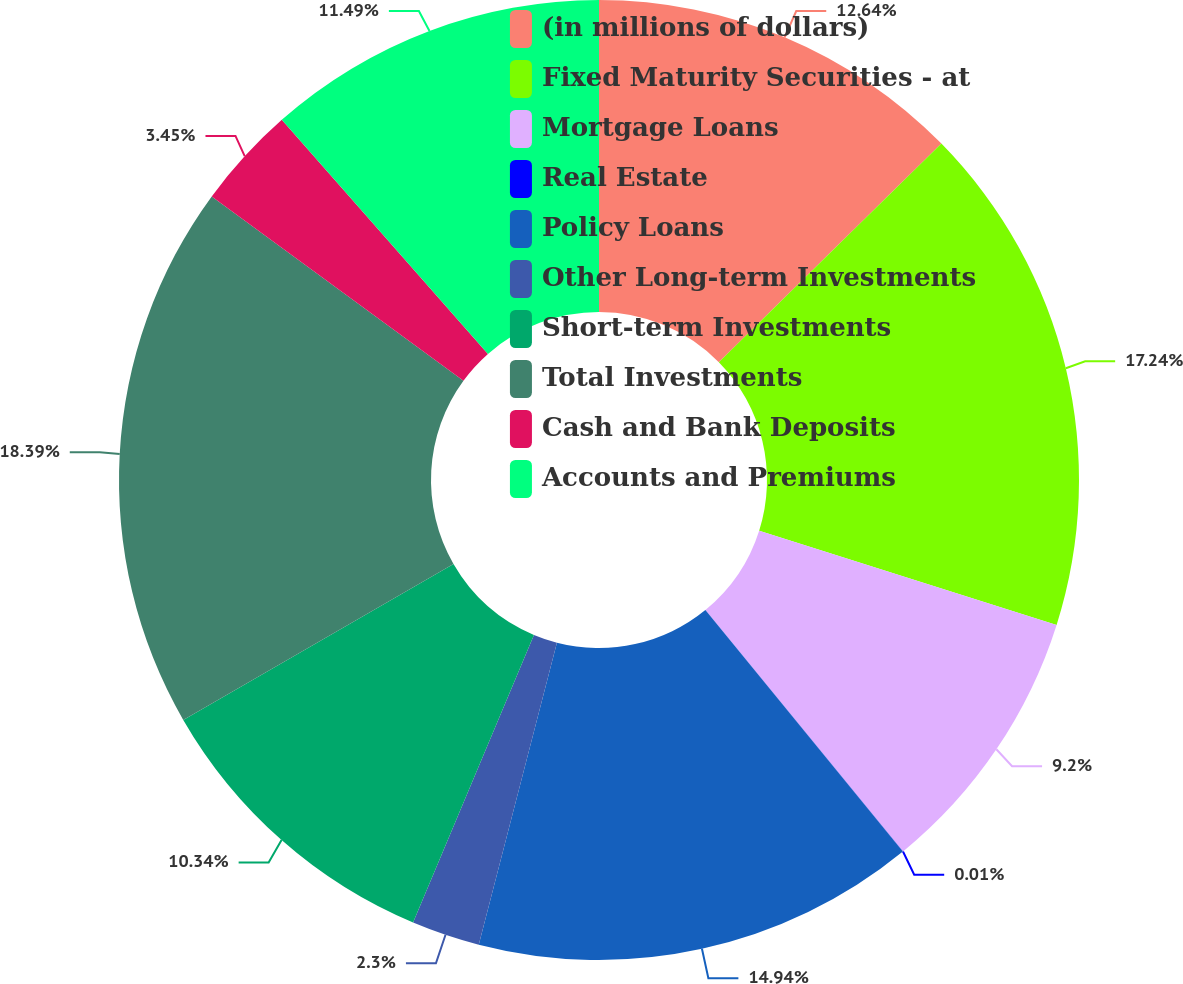Convert chart. <chart><loc_0><loc_0><loc_500><loc_500><pie_chart><fcel>(in millions of dollars)<fcel>Fixed Maturity Securities - at<fcel>Mortgage Loans<fcel>Real Estate<fcel>Policy Loans<fcel>Other Long-term Investments<fcel>Short-term Investments<fcel>Total Investments<fcel>Cash and Bank Deposits<fcel>Accounts and Premiums<nl><fcel>12.64%<fcel>17.24%<fcel>9.2%<fcel>0.01%<fcel>14.94%<fcel>2.3%<fcel>10.34%<fcel>18.39%<fcel>3.45%<fcel>11.49%<nl></chart> 